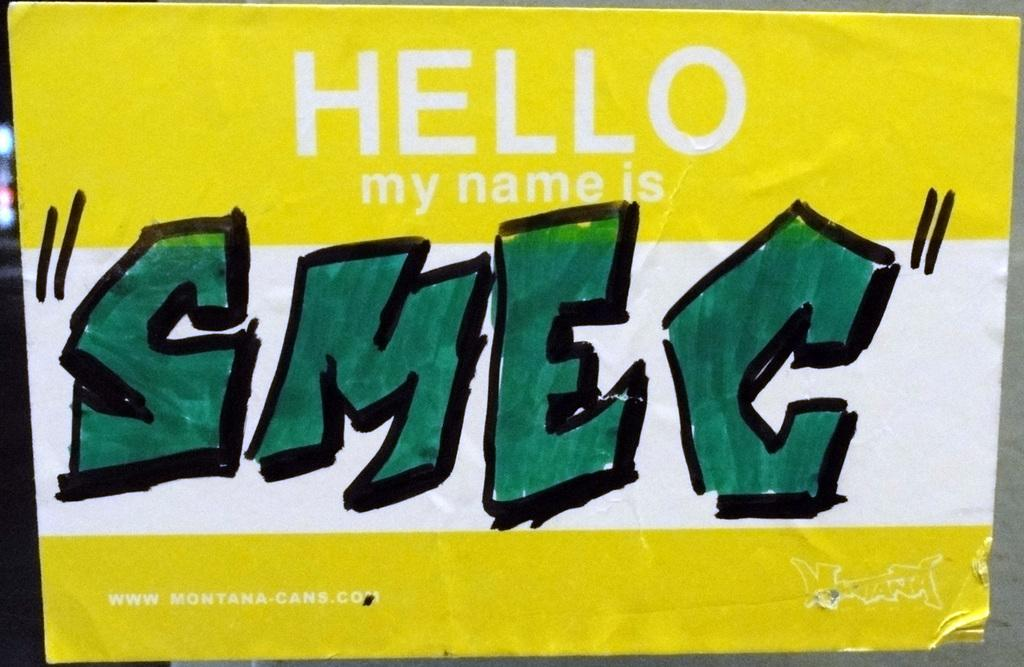What is the main object in the image? There is a board in the image. What can be seen on the board? There is writing on the board. What type of shop can be seen in the image? There is no shop present in the image; it only features a board with writing on it. How does the board turn in the image? The board does not turn in the image; it is stationary. 